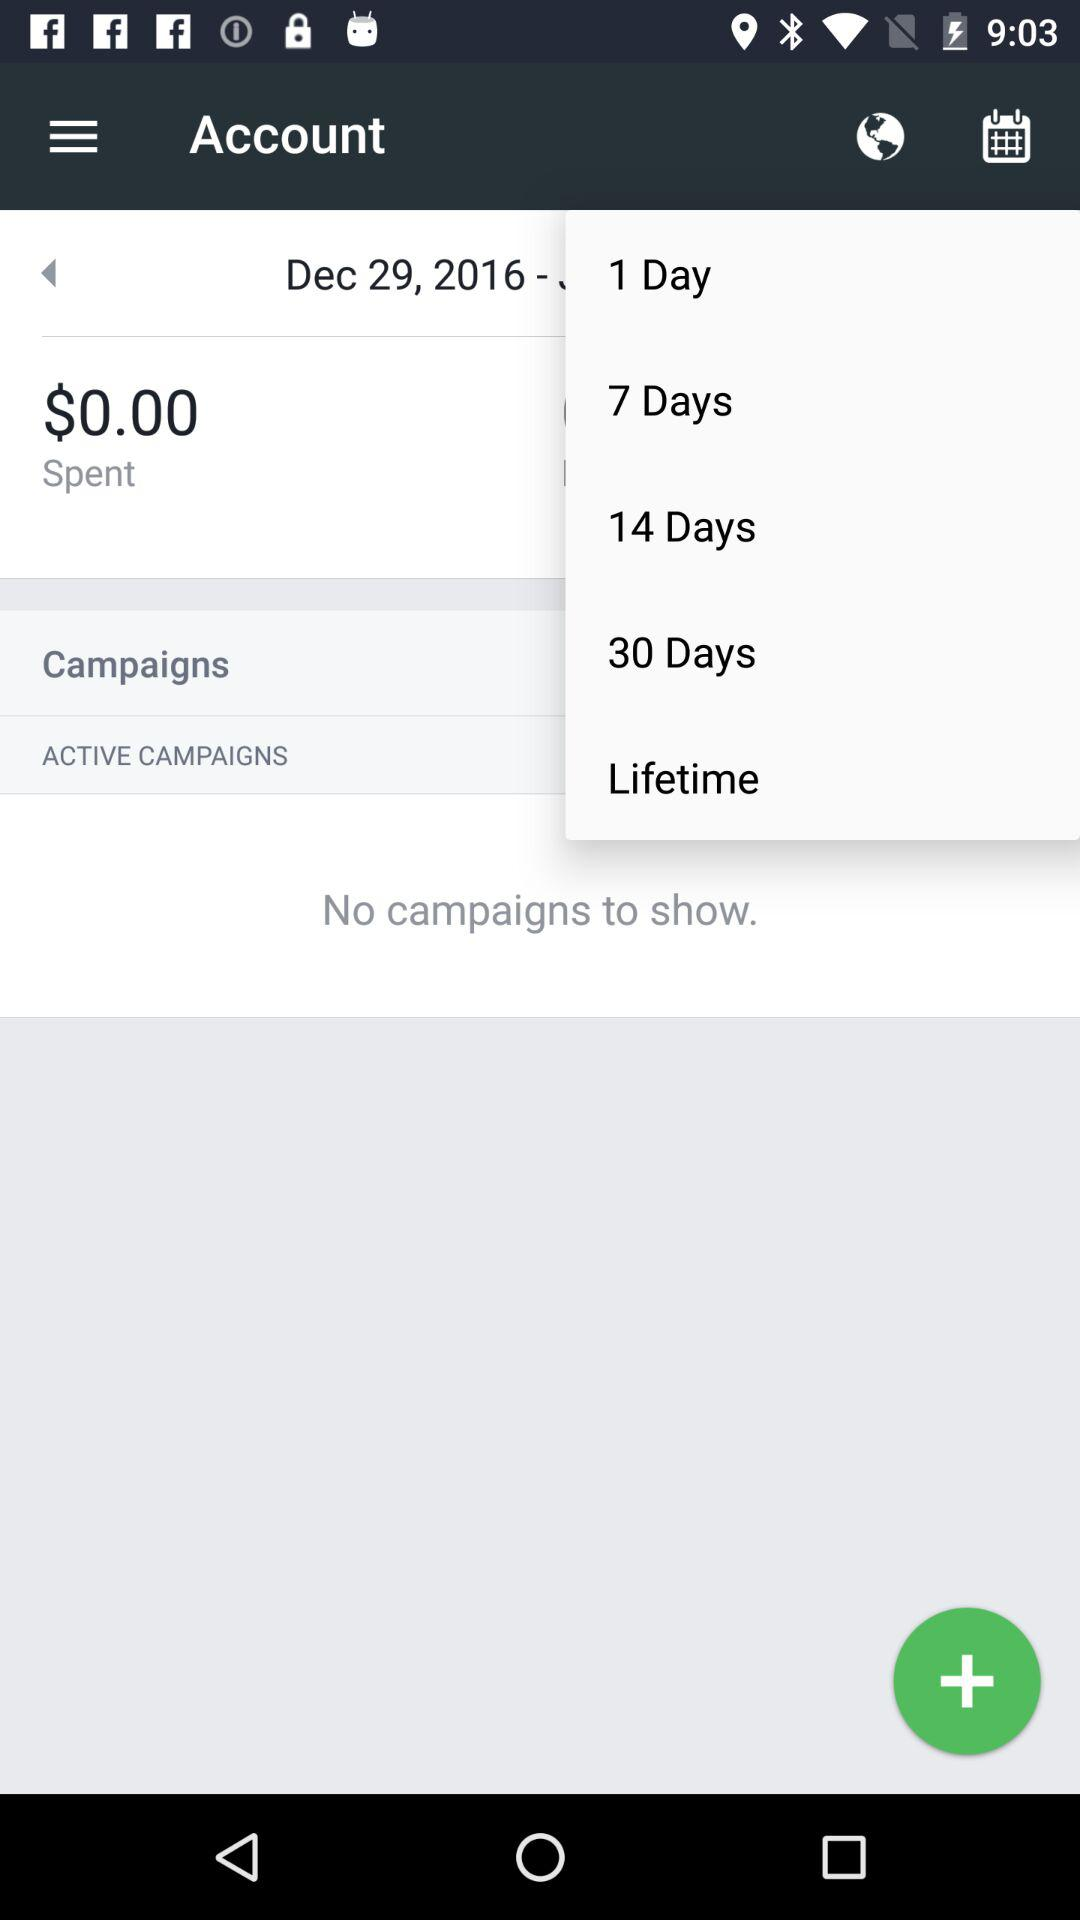How much money was spent? The spent money was $0. 